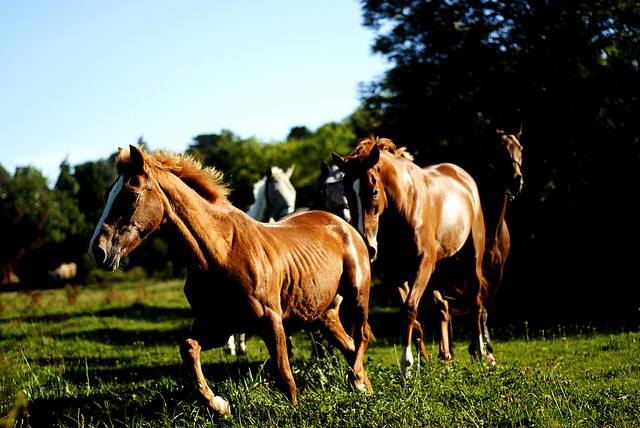Describe the objects in this image and their specific colors. I can see horse in lightblue, black, orange, brown, and maroon tones, horse in lightblue, black, tan, and red tones, horse in lightblue, black, maroon, brown, and olive tones, horse in lightblue, black, ivory, teal, and tan tones, and horse in lightblue, black, olive, gray, and lightgray tones in this image. 